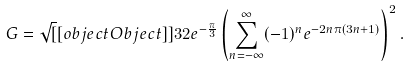<formula> <loc_0><loc_0><loc_500><loc_500>G = { \sqrt { [ } [ o b j e c t O b j e c t ] ] { 3 2 } } e ^ { - { \frac { \pi } { 3 } } } \left ( \sum _ { n = - \infty } ^ { \infty } ( - 1 ) ^ { n } e ^ { - 2 n \pi ( 3 n + 1 ) } \right ) ^ { 2 } .</formula> 